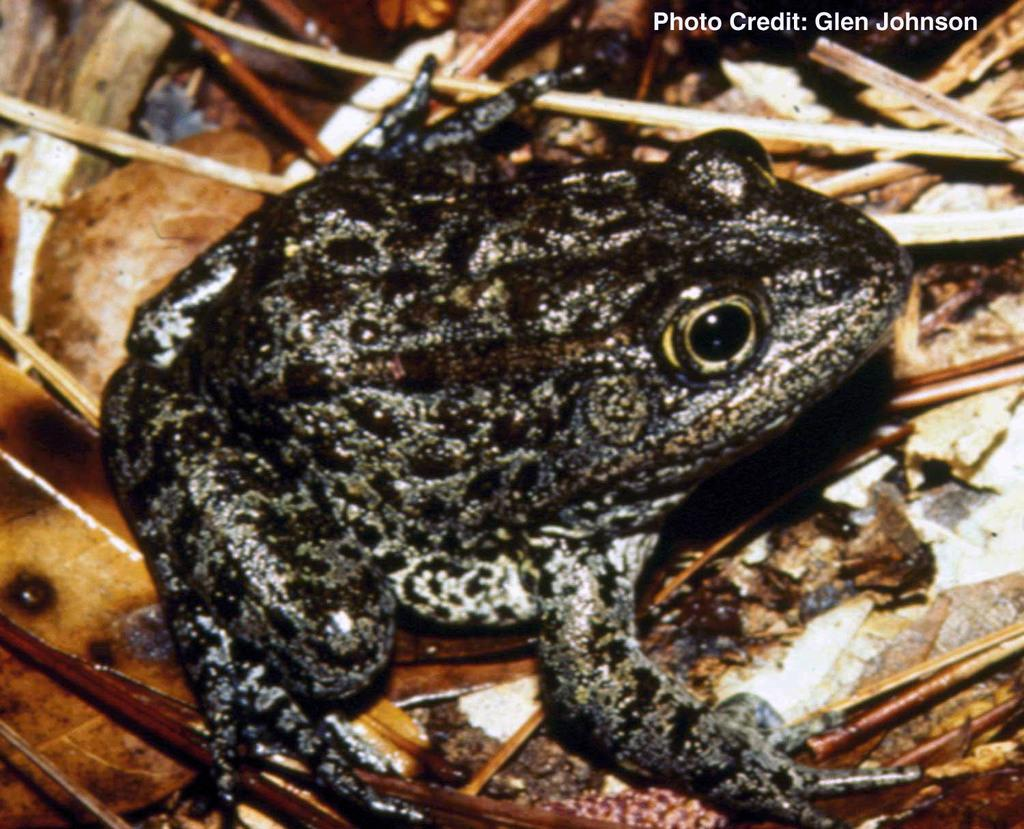What type of animal is in the image? There is a frog in the image. Where is the frog located? The frog is on the floor. What else can be seen on the floor in the image? There are twigs and leaves on the floor. What type of pies are being served on the side of the image? There are no pies present in the image. 